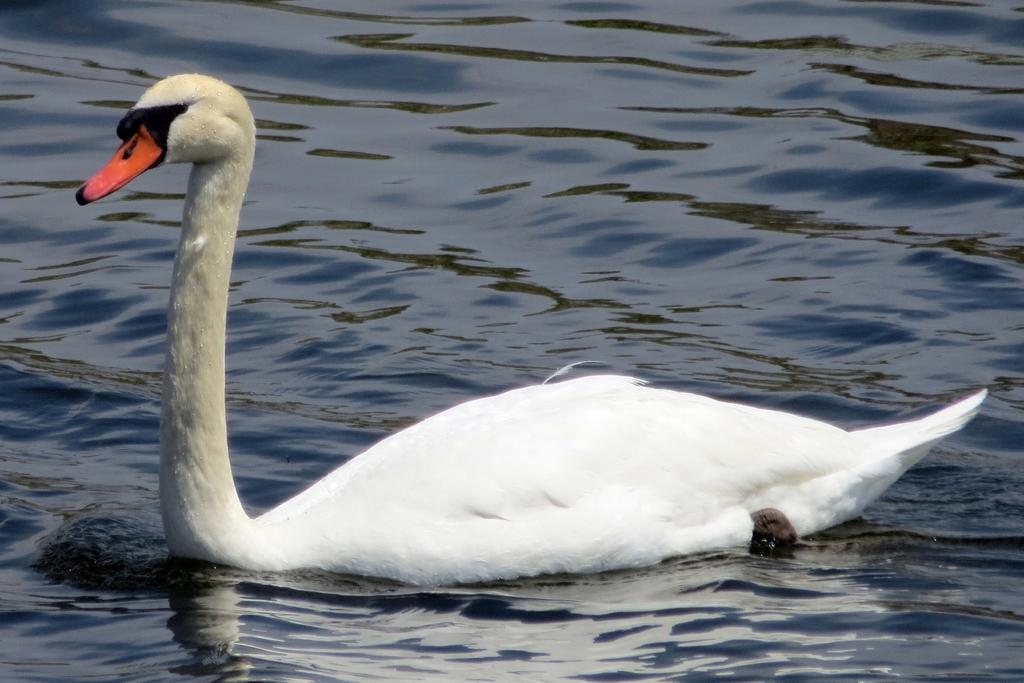What animal is present in the image? There is a duck in the image. Where is the duck located? The duck is in the water. What type of curve can be seen on the moon in the image? There is no moon present in the image, and therefore no curve can be observed on it. 